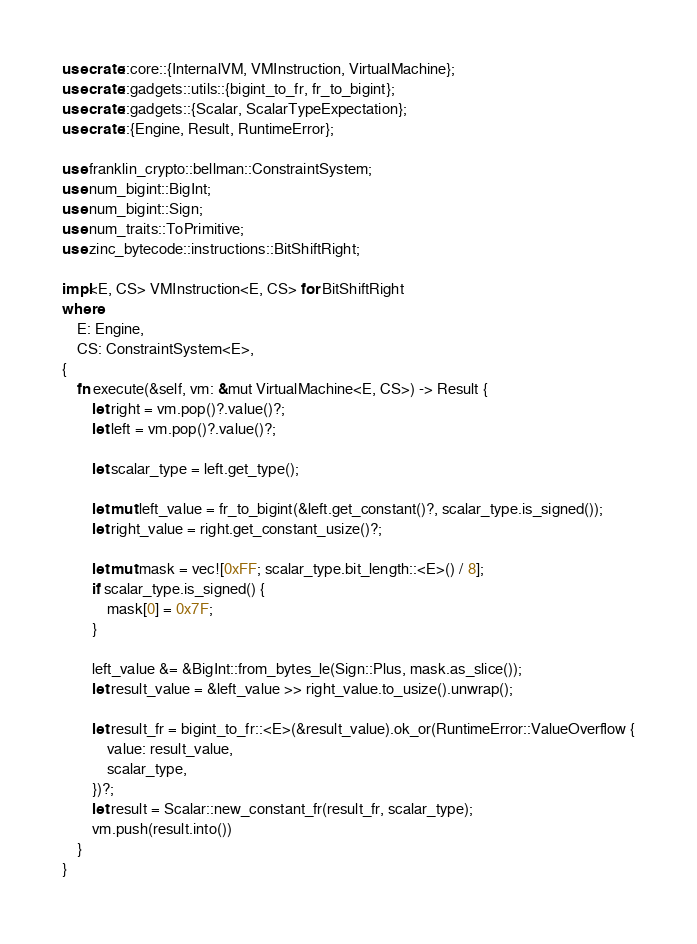<code> <loc_0><loc_0><loc_500><loc_500><_Rust_>use crate::core::{InternalVM, VMInstruction, VirtualMachine};
use crate::gadgets::utils::{bigint_to_fr, fr_to_bigint};
use crate::gadgets::{Scalar, ScalarTypeExpectation};
use crate::{Engine, Result, RuntimeError};

use franklin_crypto::bellman::ConstraintSystem;
use num_bigint::BigInt;
use num_bigint::Sign;
use num_traits::ToPrimitive;
use zinc_bytecode::instructions::BitShiftRight;

impl<E, CS> VMInstruction<E, CS> for BitShiftRight
where
    E: Engine,
    CS: ConstraintSystem<E>,
{
    fn execute(&self, vm: &mut VirtualMachine<E, CS>) -> Result {
        let right = vm.pop()?.value()?;
        let left = vm.pop()?.value()?;

        let scalar_type = left.get_type();

        let mut left_value = fr_to_bigint(&left.get_constant()?, scalar_type.is_signed());
        let right_value = right.get_constant_usize()?;

        let mut mask = vec![0xFF; scalar_type.bit_length::<E>() / 8];
        if scalar_type.is_signed() {
            mask[0] = 0x7F;
        }

        left_value &= &BigInt::from_bytes_le(Sign::Plus, mask.as_slice());
        let result_value = &left_value >> right_value.to_usize().unwrap();

        let result_fr = bigint_to_fr::<E>(&result_value).ok_or(RuntimeError::ValueOverflow {
            value: result_value,
            scalar_type,
        })?;
        let result = Scalar::new_constant_fr(result_fr, scalar_type);
        vm.push(result.into())
    }
}
</code> 